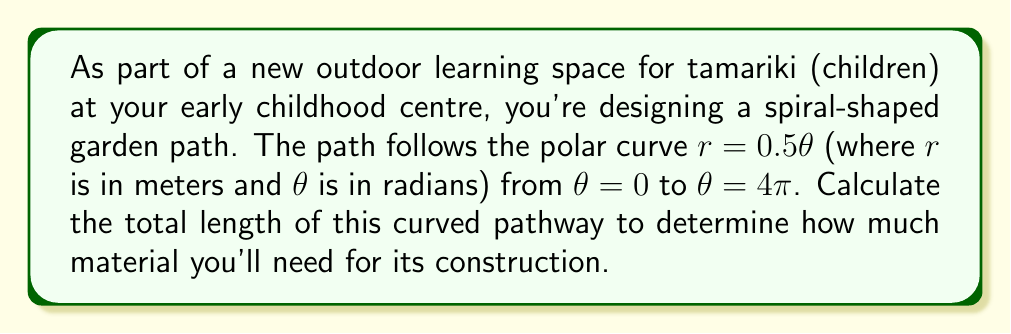What is the answer to this math problem? To solve this problem, we'll use the formula for the arc length of a polar curve:

$$L = \int_a^b \sqrt{r^2 + \left(\frac{dr}{d\theta}\right)^2} d\theta$$

Where $L$ is the length of the curve, $a$ and $b$ are the start and end values of $\theta$, and $r$ is the function of $\theta$.

Given information:
- $r = 0.5\theta$
- $\theta$ ranges from 0 to $4\pi$

Step 1: Find $\frac{dr}{d\theta}$
$$\frac{dr}{d\theta} = 0.5$$

Step 2: Substitute into the arc length formula
$$L = \int_0^{4\pi} \sqrt{(0.5\theta)^2 + (0.5)^2} d\theta$$

Step 3: Simplify under the square root
$$L = \int_0^{4\pi} \sqrt{0.25\theta^2 + 0.25} d\theta$$
$$L = 0.5 \int_0^{4\pi} \sqrt{\theta^2 + 1} d\theta$$

Step 4: This integral is of the form $\int \sqrt{x^2 + 1} dx$, which has the solution:
$$\frac{1}{2}\left(x\sqrt{x^2+1} + \ln|x + \sqrt{x^2+1}|\right) + C$$

Step 5: Apply the limits of integration
$$L = 0.5 \left[\frac{1}{2}\left(\theta\sqrt{\theta^2+1} + \ln|\theta + \sqrt{\theta^2+1}|\right)\right]_0^{4\pi}$$

Step 6: Evaluate
$$L = 0.25 \left[(4\pi\sqrt{16\pi^2+1} + \ln|4\pi + \sqrt{16\pi^2+1}|) - (0 + \ln 1)\right]$$

Step 7: Simplify and calculate (using a calculator for the numerical values)
$$L \approx 25.13 \text{ meters}$$

This result represents the total length of the spiral path in meters.
Answer: The total length of the spiral-shaped garden path is approximately 25.13 meters. 